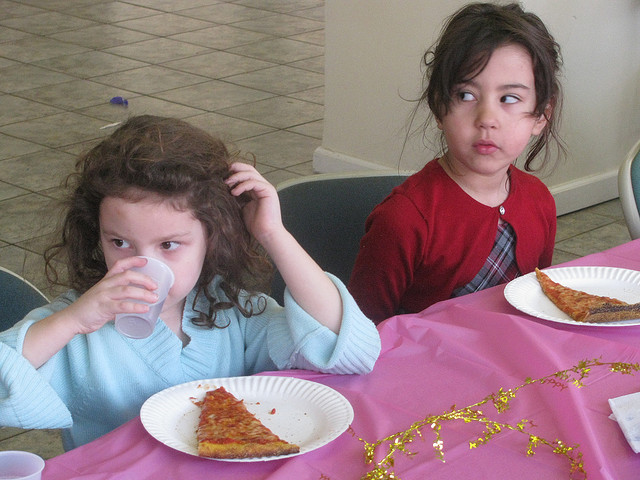<image>What is the girl in the red shirt looking at? It is unclear what the girl in the red shirt is looking at, as she could be looking at a person, something to her side, or something behind her. What is the girl in the red shirt looking at? I don't know what the girl in the red shirt is looking at. It can be a person, something to the side, or something behind her. 